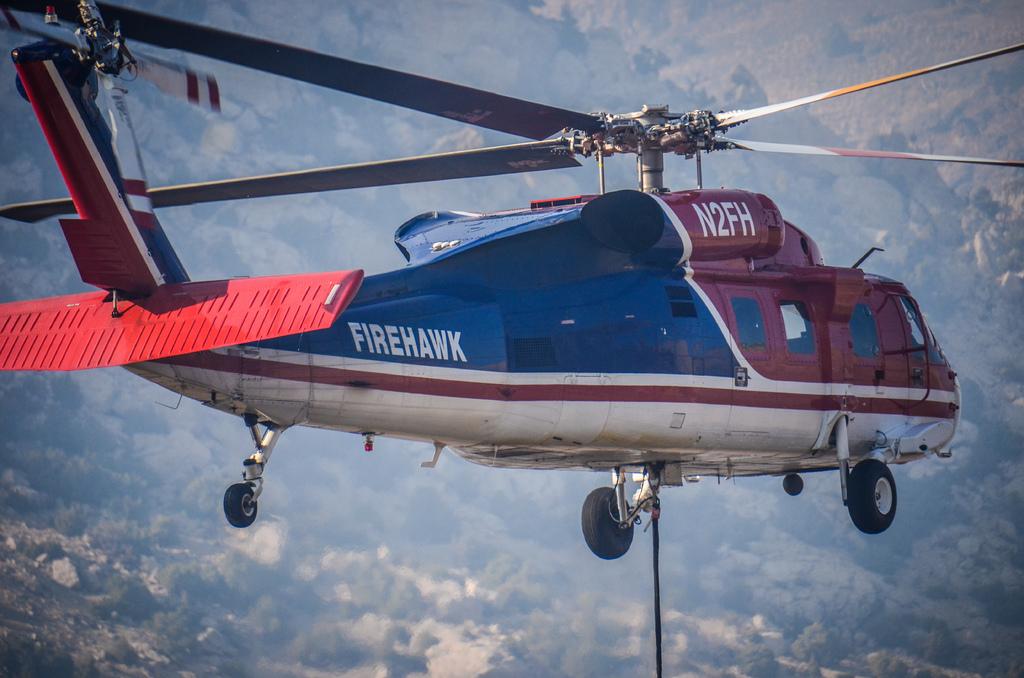What is wrote on the helicopter on the left bottom?
Offer a terse response. Firehawk. What is this helicopter called?
Provide a succinct answer. Firehawk. 